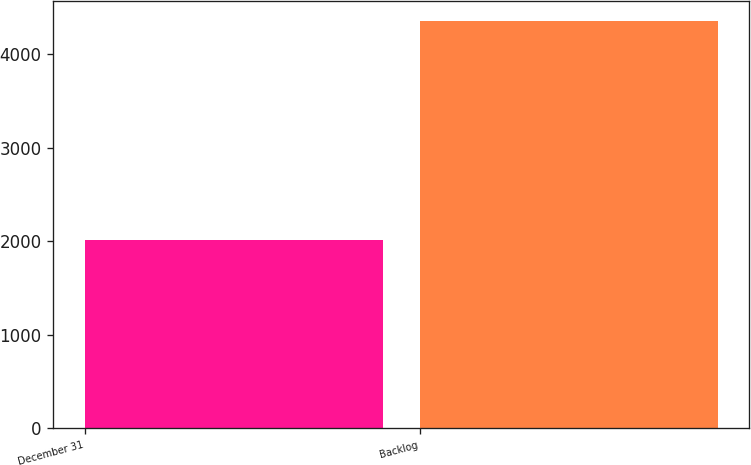Convert chart. <chart><loc_0><loc_0><loc_500><loc_500><bar_chart><fcel>December 31<fcel>Backlog<nl><fcel>2015<fcel>4352<nl></chart> 